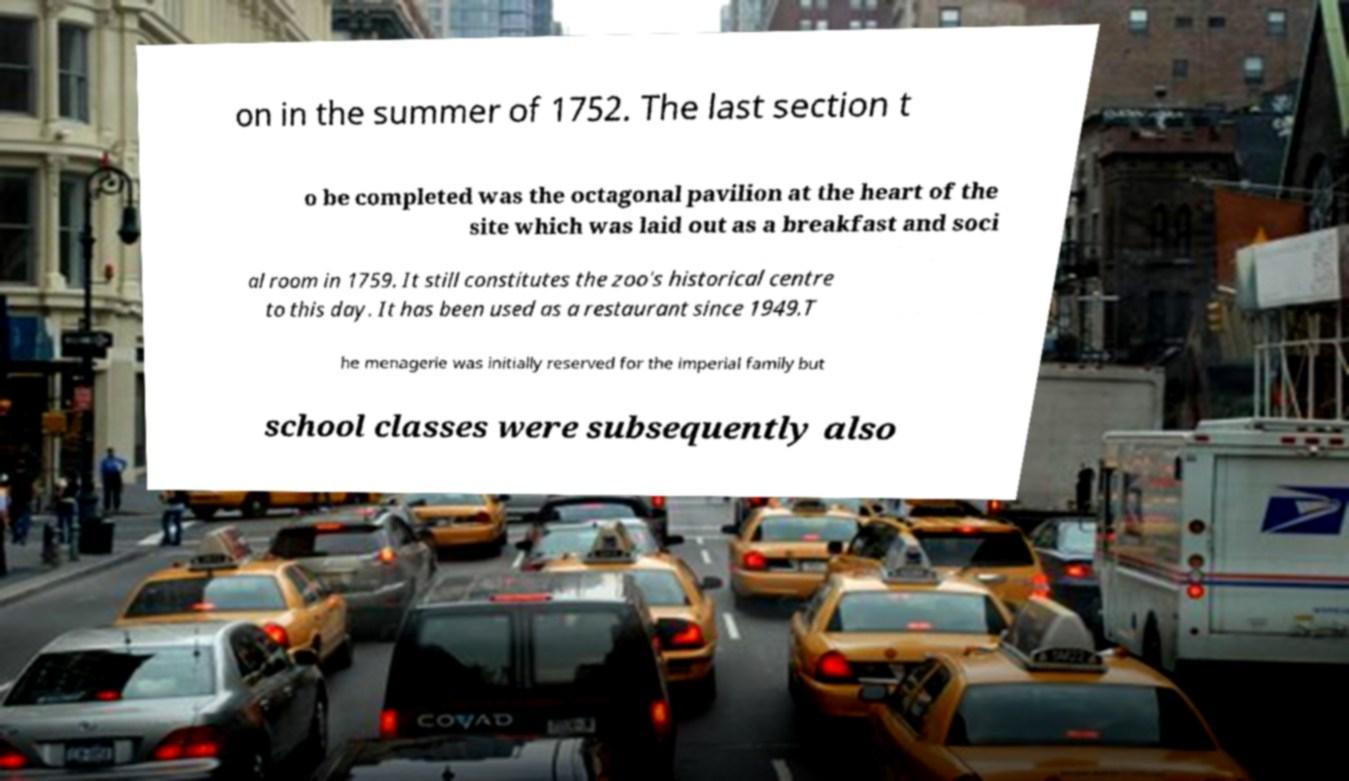Please identify and transcribe the text found in this image. on in the summer of 1752. The last section t o be completed was the octagonal pavilion at the heart of the site which was laid out as a breakfast and soci al room in 1759. It still constitutes the zoo's historical centre to this day. It has been used as a restaurant since 1949.T he menagerie was initially reserved for the imperial family but school classes were subsequently also 